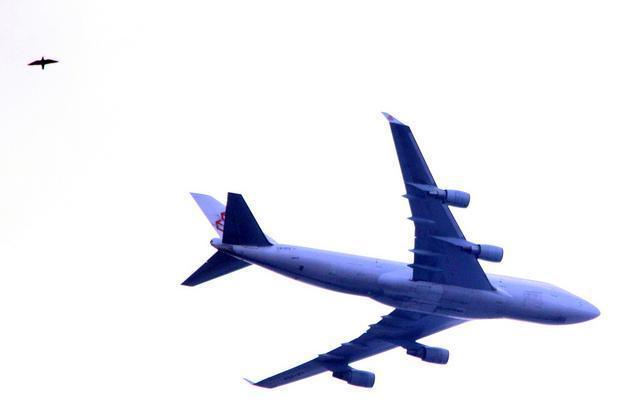How many engines does the plane have?
Give a very brief answer. 4. How many letters are in the bus name?
Give a very brief answer. 0. 